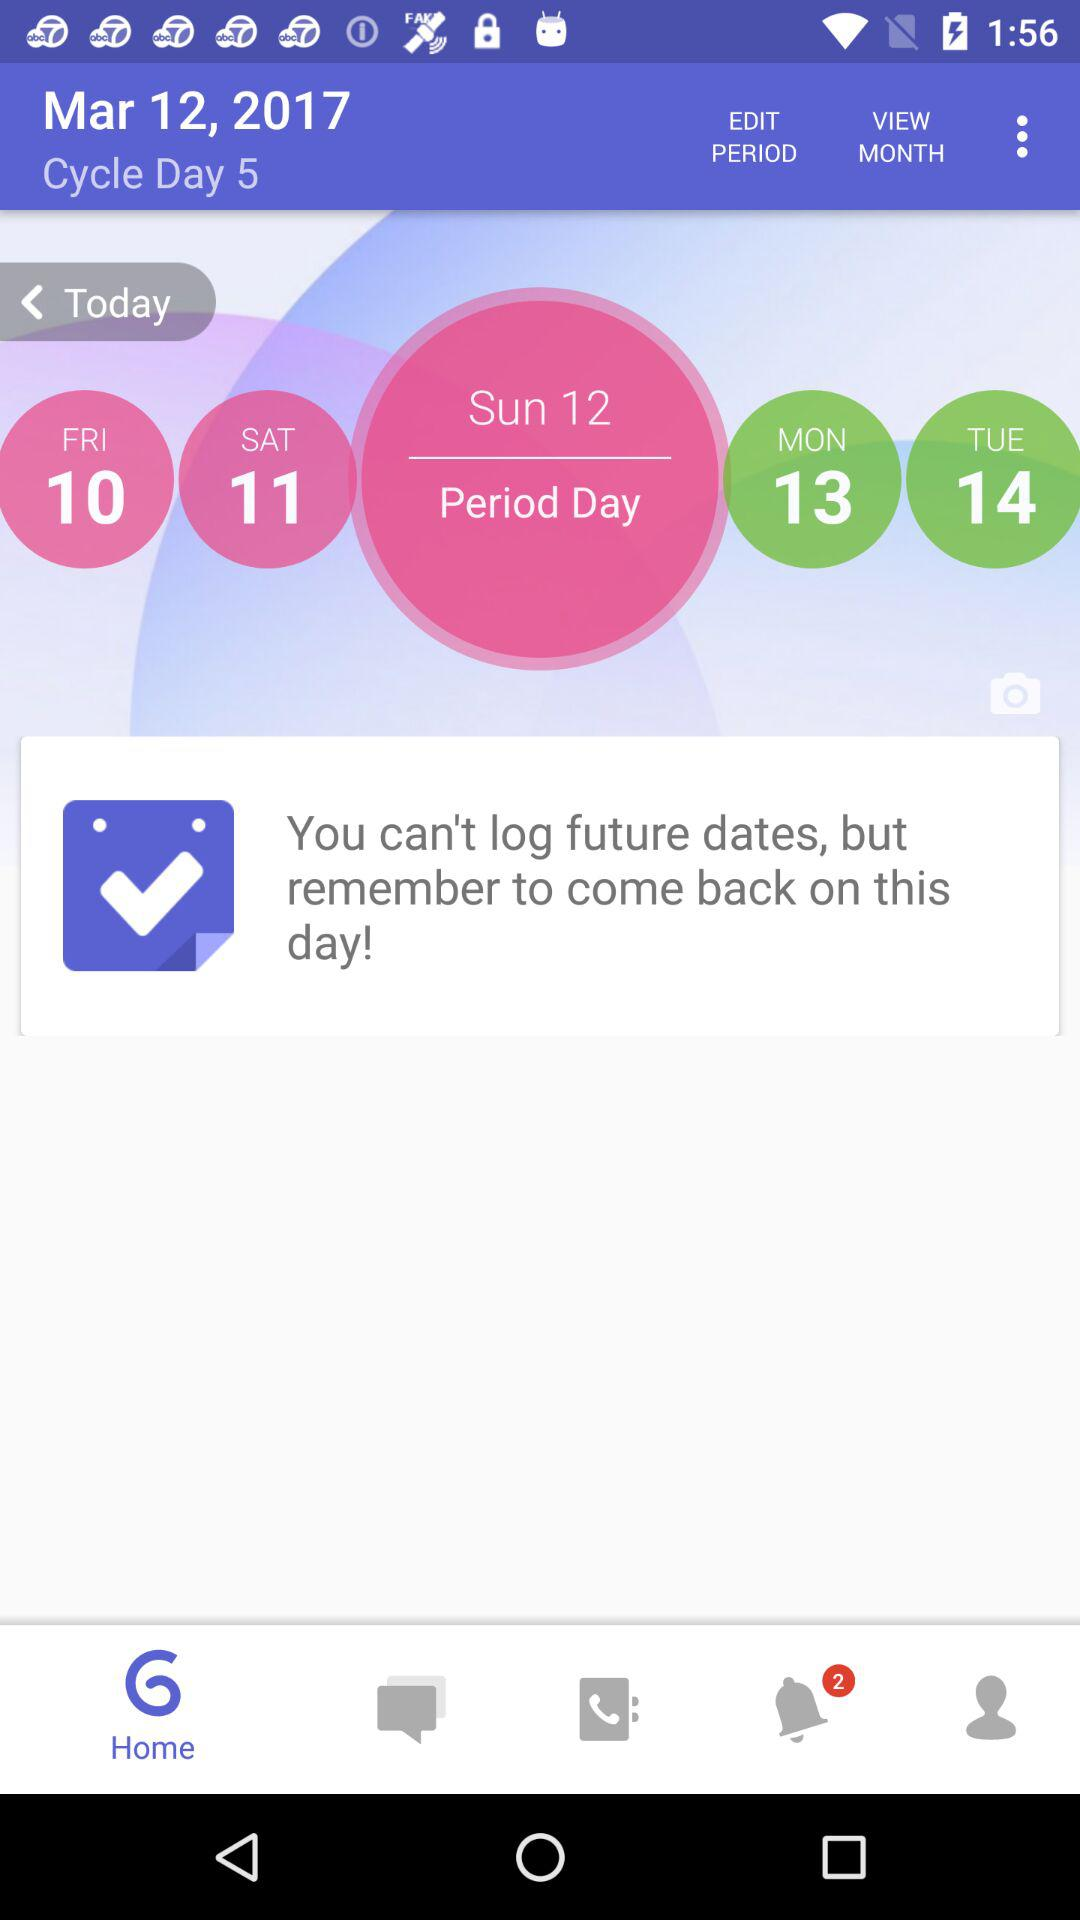How many days are in the current cycle?
Answer the question using a single word or phrase. 5 